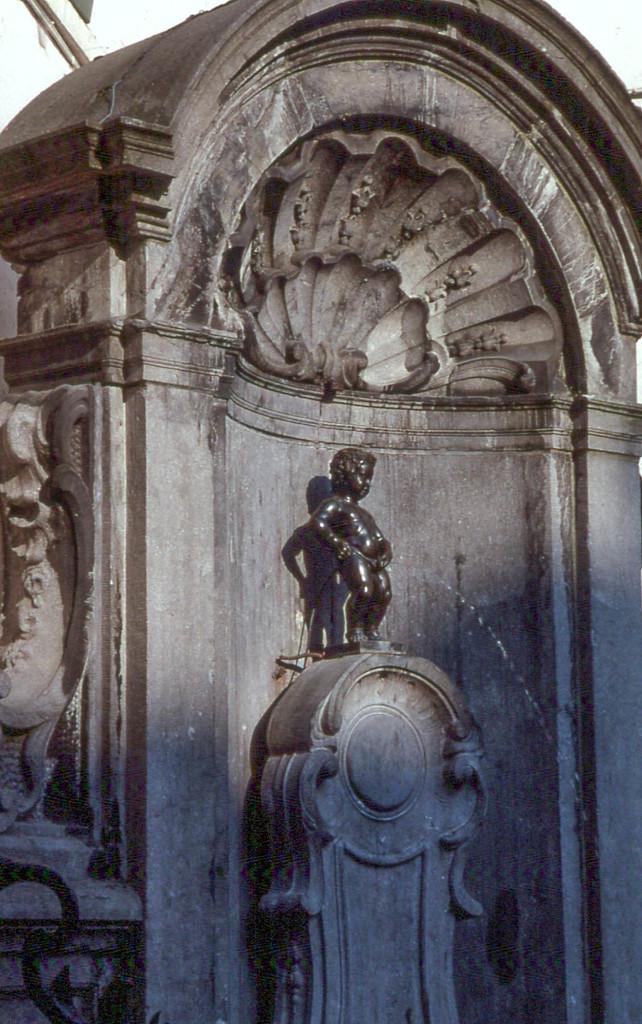Describe this image in one or two sentences. This picture contains sculpture and the statue of the boy is standing on the pillar. 